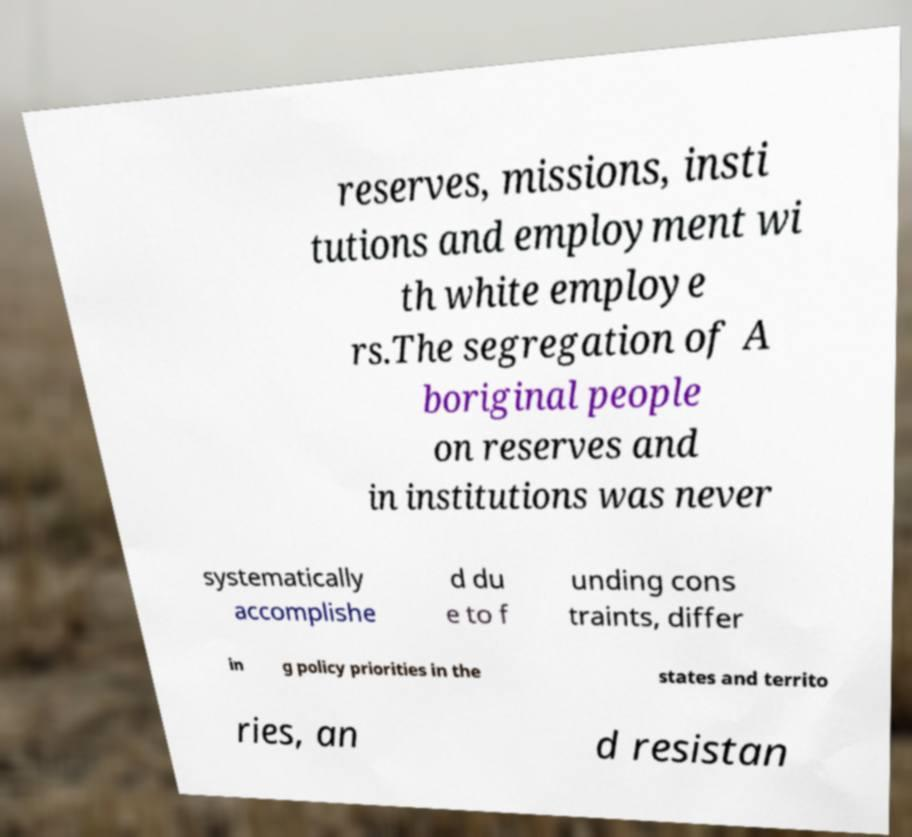Can you read and provide the text displayed in the image?This photo seems to have some interesting text. Can you extract and type it out for me? reserves, missions, insti tutions and employment wi th white employe rs.The segregation of A boriginal people on reserves and in institutions was never systematically accomplishe d du e to f unding cons traints, differ in g policy priorities in the states and territo ries, an d resistan 